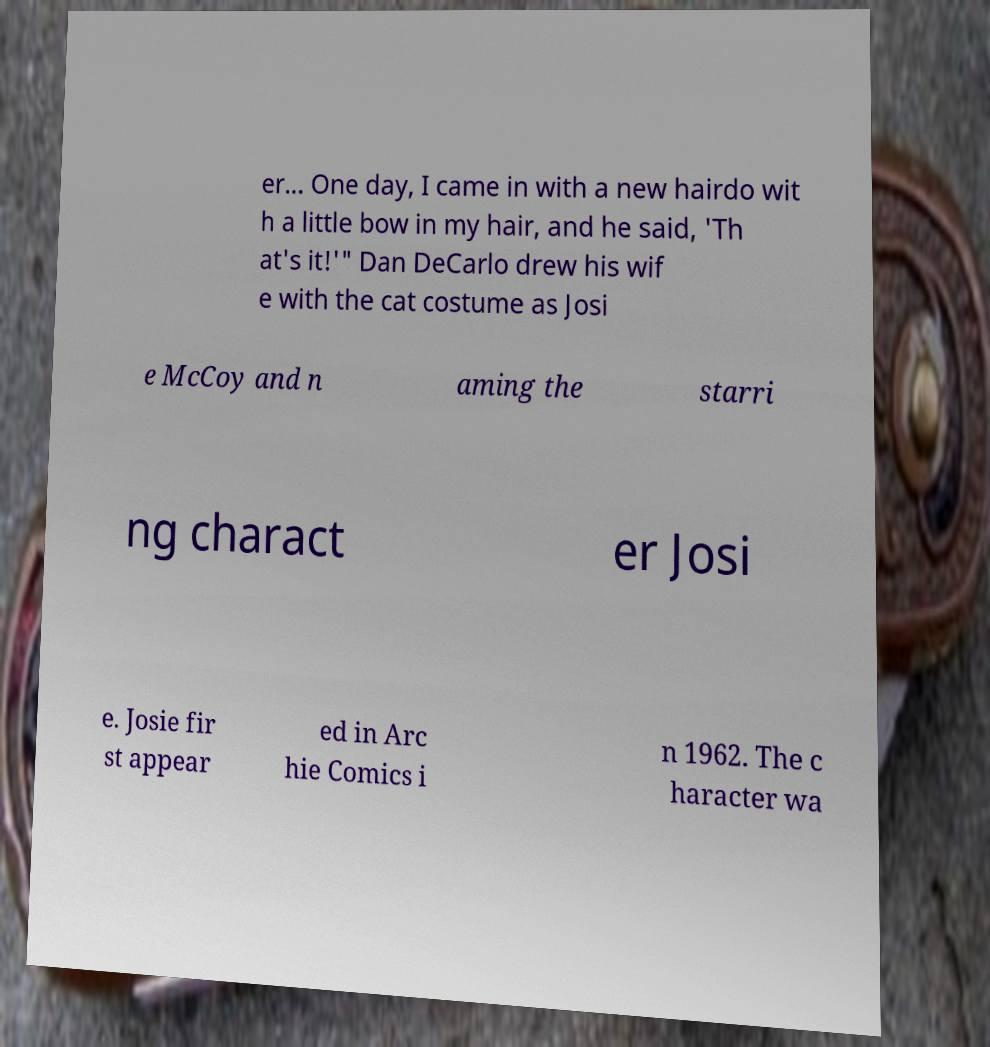I need the written content from this picture converted into text. Can you do that? er... One day, I came in with a new hairdo wit h a little bow in my hair, and he said, 'Th at's it!'" Dan DeCarlo drew his wif e with the cat costume as Josi e McCoy and n aming the starri ng charact er Josi e. Josie fir st appear ed in Arc hie Comics i n 1962. The c haracter wa 